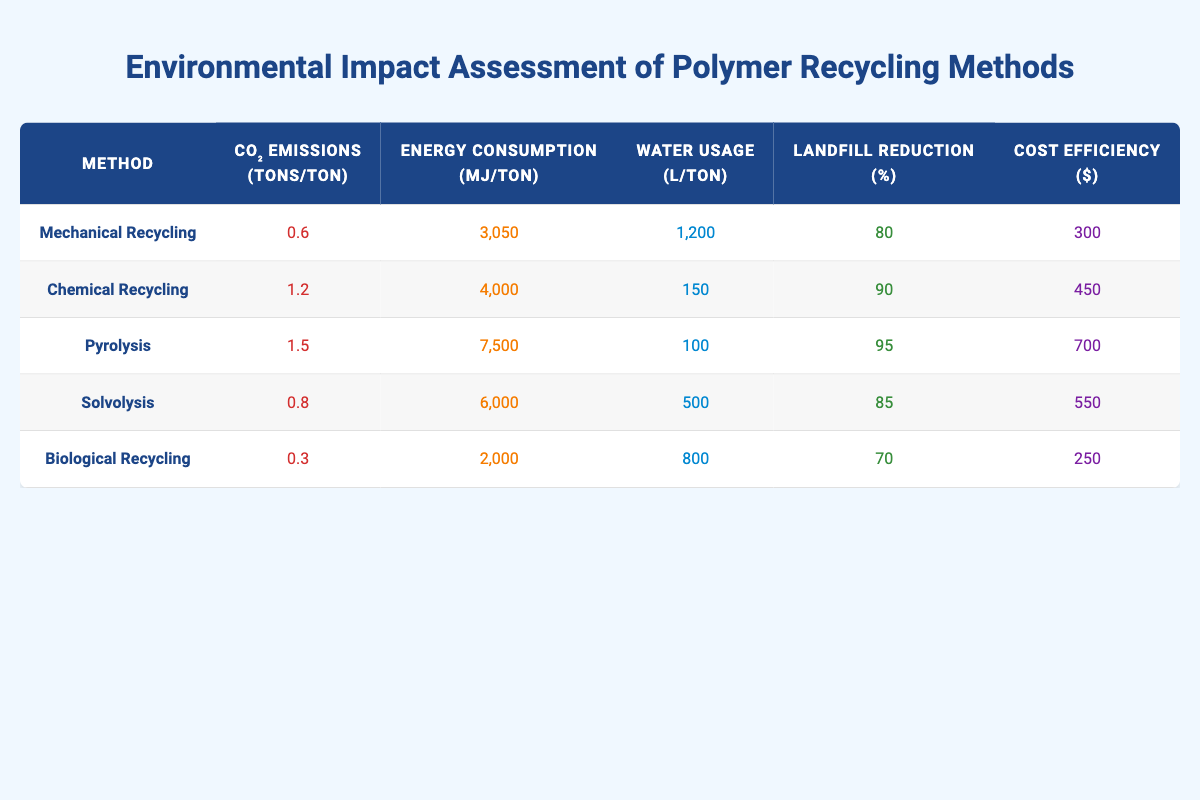What is the CO₂ emissions for Biological Recycling? Looking at the row for Biological Recycling in the table, the CO₂ emissions value listed is 0.3 tons per ton of recycled polymer.
Answer: 0.3 Which recycling method has the highest landfill reduction percentage? By comparing the landfill reduction percentages for all methods, Pyrolysis has the highest value with 95%.
Answer: 95 What is the energy consumption for Chemical Recycling? The row corresponding to Chemical Recycling shows an energy consumption of 4000 MJ per ton.
Answer: 4000 What is the average water usage across all recycling methods? First, we sum the water usage values: 1200 + 150 + 100 + 500 + 800 = 2850. Next, we divide by the number of methods (5), giving an average of 2850 / 5 = 570.
Answer: 570 Is Mechanical Recycling more cost-efficient than Biological Recycling? The cost efficiency value for Mechanical Recycling is 300, while for Biological Recycling it is 250. Since 300 is greater than 250, the statement is true.
Answer: Yes What is the difference in CO₂ emissions between Pyrolysis and Solvolysis? Looking at the CO₂ emissions for Pyrolysis (1.5) and Solvolysis (0.8), the difference is 1.5 - 0.8 = 0.7 tons per ton.
Answer: 0.7 Which recycling method uses the least water? The water usage values show that Chemical Recycling uses 150 L per ton, which is the lowest among all methods.
Answer: 150 Which method has the lowest cost efficiency? By examining the cost efficiency values, Biological Recycling has the lowest at 250 dollars.
Answer: 250 How much more energy does Pyrolysis consume compared to Biological Recycling? The energy consumption for Pyrolysis is 7500 MJ per ton, and for Biological Recycling it is 2000 MJ per ton. The difference is 7500 - 2000 = 5500 MJ per ton.
Answer: 5500 Is it true that all recycling methods have a landfill reduction percentage greater than 70%? By reviewing the landfill reduction values, all methods indeed have percentages above 70%, validating the statement as true.
Answer: Yes 